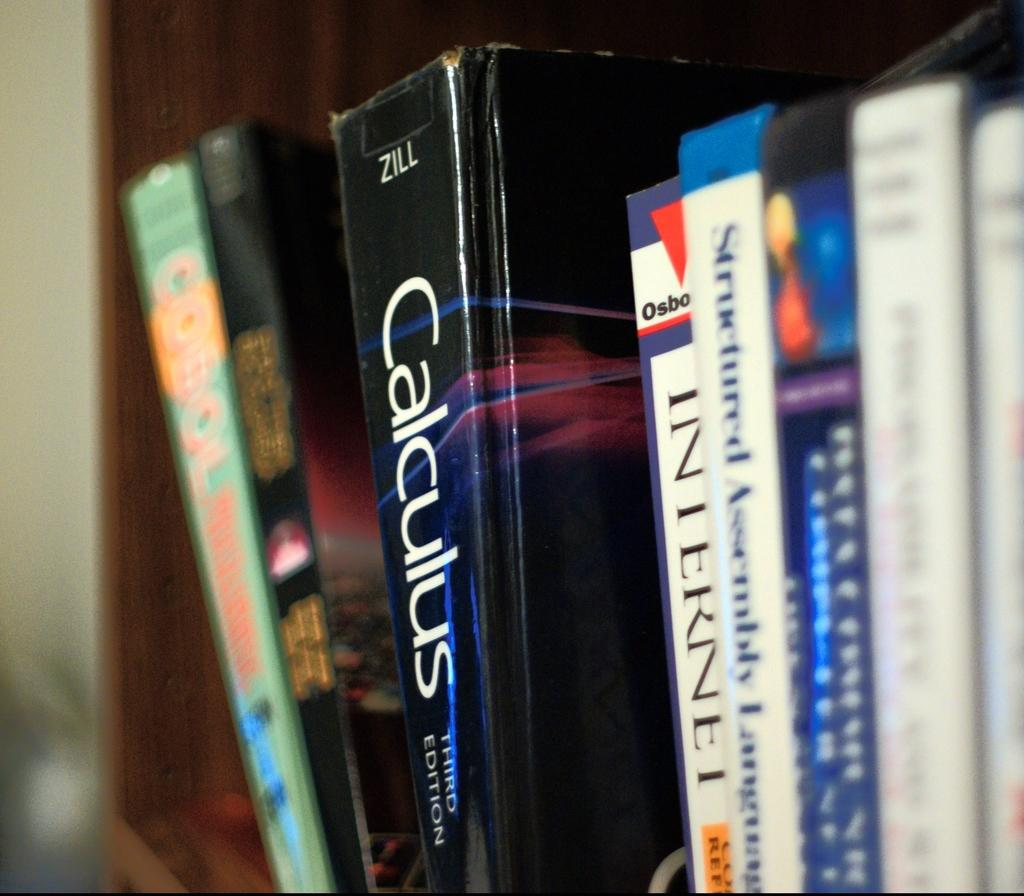What objects can be seen in the image? There are books in a bookshelf in the image. Can you describe the arrangement of the books? The books are arranged on a bookshelf, which suggests they are organized in some manner. What might the purpose of the bookshelf be? The bookshelf is likely used for storing and organizing books. What type of mist can be seen surrounding the throne in the image? There is no throne or mist present in the image; it only features a bookshelf with books. 